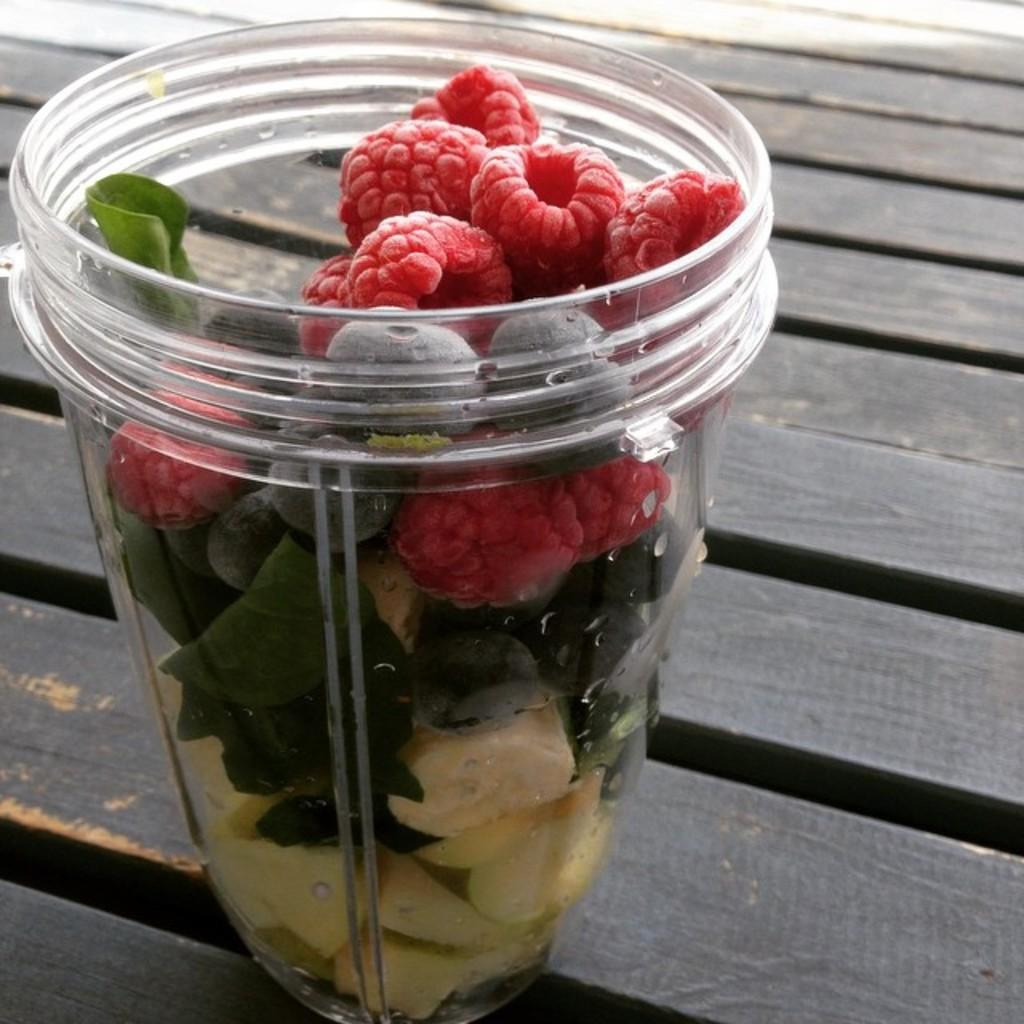What type of food items are in the glass in the image? The facts do not specify the type of food items in the glass. What is visible in the background of the image? There is a table in the background of the image. How much oil is present in the image? There is no mention of oil in the image, so it cannot be determined how much oil is present. 